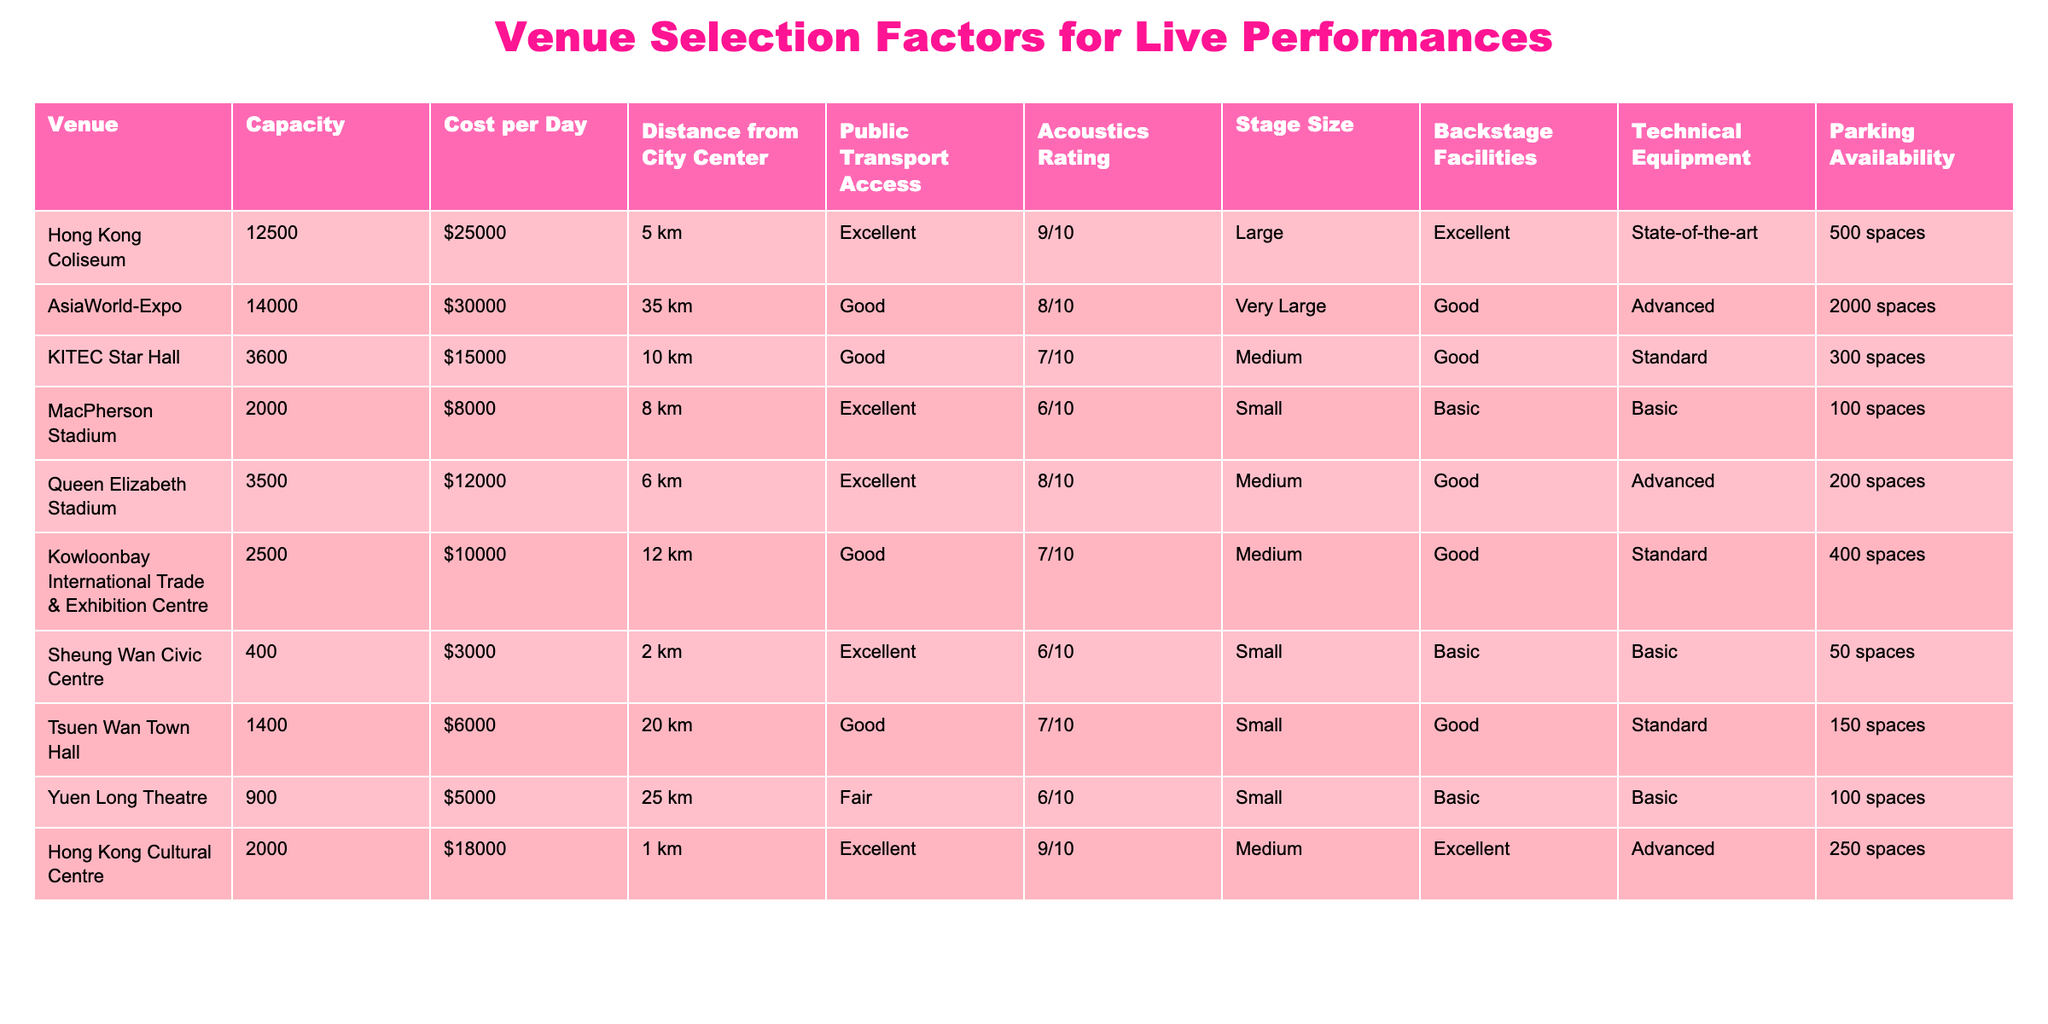What is the capacity of the Hong Kong Coliseum? Referring to the table, the capacity for the Hong Kong Coliseum is directly listed as 12500.
Answer: 12500 How much does it cost per day to rent MacPherson Stadium? According to the table, the cost per day to rent MacPherson Stadium is listed as $8000.
Answer: $8000 Which venue has the best public transport access? The table indicates that the Hong Kong Coliseum and Sheung Wan Civic Centre both have "Excellent" public transport access, which is the highest rating available.
Answer: Hong Kong Coliseum and Sheung Wan Civic Centre What is the stage size of the AsiaWorld-Expo? The table shows that the stage size for AsiaWorld-Expo is classified as "Very Large."
Answer: Very Large What is the average cost per day of the venues listed? To find the average cost, we sum the costs: (25000 + 30000 + 15000 + 8000 + 12000 + 10000 + 3000 + 6000 + 5000 + 18000) = 115000. Then, divide by the number of venues (10): 115000 / 10 = 11500.
Answer: 11500 Is there any venue with a capacity of less than 1000? Reviewing the table, it shows that all venues listed have a capacity greater than 1000; therefore, the statement is false.
Answer: No Which venue has the largest parking availability? From the table, the AsiaWorld-Expo has the largest parking availability at 2000 spaces. We compare all parking availability values, and AsiaWorld-Expo has the maximum.
Answer: AsiaWorld-Expo How many venues have an acoustics rating of 9/10? The table lists the venues with an acoustics rating of 9/10 and we find that there are two: Hong Kong Cultural Centre and Hong Kong Coliseum.
Answer: 2 What is the difference in distance from the city center between the farthest and closest venue? The farthest venue is AsiaWorld-Expo at 35 km and the closest is Hong Kong Cultural Centre at 1 km. The difference is 35 - 1 = 34 km.
Answer: 34 km How many venues have both excellent acoustics and backstage facilities? By reviewing the table, the venues with both excellent acoustics (Hong Kong Coliseum and Hong Kong Cultural Centre) and excellent backstage facilities include only these two venues; hence, the answer is two.
Answer: 2 